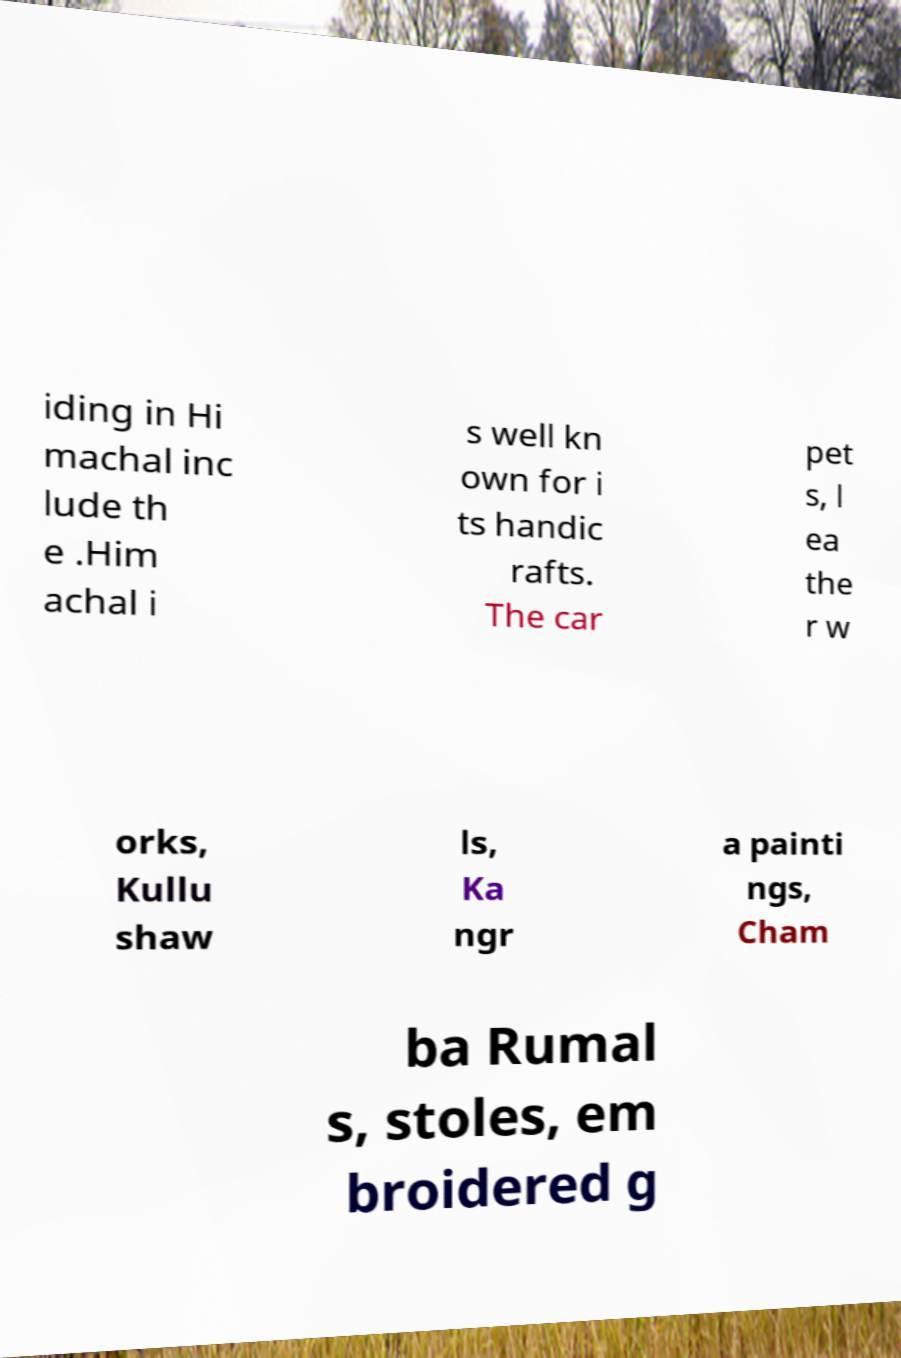For documentation purposes, I need the text within this image transcribed. Could you provide that? iding in Hi machal inc lude th e .Him achal i s well kn own for i ts handic rafts. The car pet s, l ea the r w orks, Kullu shaw ls, Ka ngr a painti ngs, Cham ba Rumal s, stoles, em broidered g 